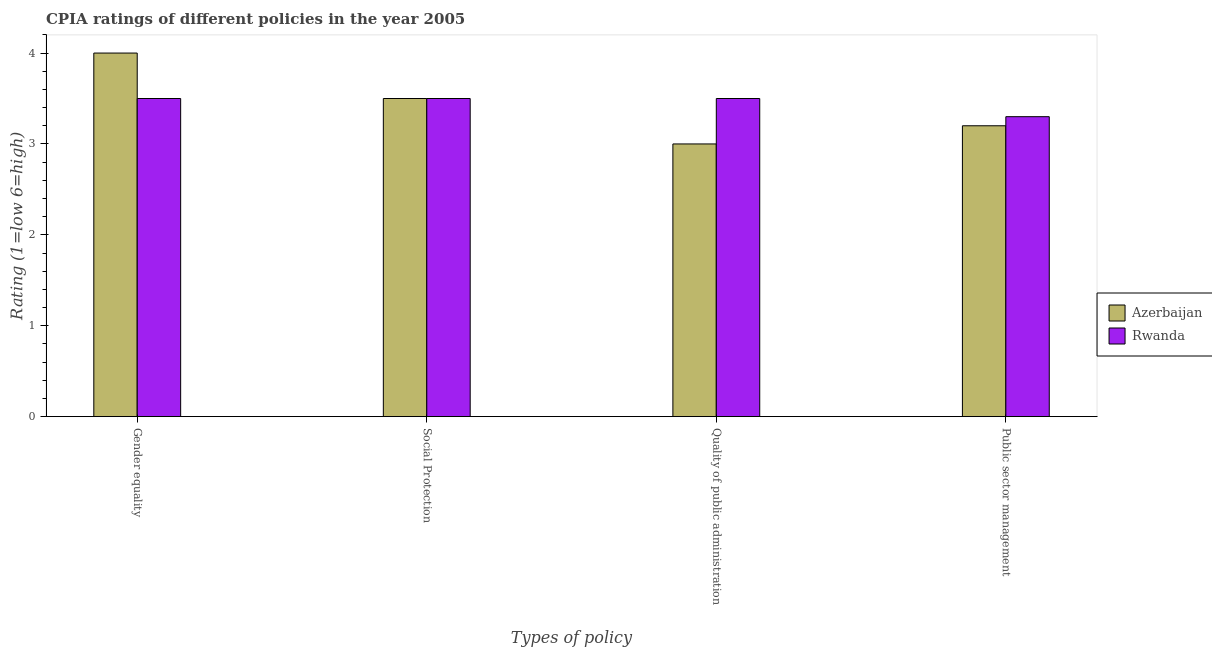How many different coloured bars are there?
Provide a succinct answer. 2. How many groups of bars are there?
Make the answer very short. 4. Are the number of bars on each tick of the X-axis equal?
Keep it short and to the point. Yes. How many bars are there on the 4th tick from the left?
Offer a very short reply. 2. What is the label of the 4th group of bars from the left?
Your answer should be very brief. Public sector management. In which country was the cpia rating of gender equality maximum?
Ensure brevity in your answer.  Azerbaijan. In which country was the cpia rating of social protection minimum?
Offer a very short reply. Azerbaijan. What is the total cpia rating of social protection in the graph?
Make the answer very short. 7. What is the difference between the cpia rating of social protection in Rwanda and that in Azerbaijan?
Keep it short and to the point. 0. What is the average cpia rating of gender equality per country?
Your answer should be very brief. 3.75. What is the difference between the cpia rating of public sector management and cpia rating of social protection in Azerbaijan?
Your answer should be very brief. -0.3. What is the ratio of the cpia rating of quality of public administration in Azerbaijan to that in Rwanda?
Your response must be concise. 0.86. Is the difference between the cpia rating of quality of public administration in Rwanda and Azerbaijan greater than the difference between the cpia rating of social protection in Rwanda and Azerbaijan?
Offer a very short reply. Yes. What is the difference between the highest and the lowest cpia rating of quality of public administration?
Make the answer very short. 0.5. Is the sum of the cpia rating of gender equality in Azerbaijan and Rwanda greater than the maximum cpia rating of public sector management across all countries?
Ensure brevity in your answer.  Yes. What does the 1st bar from the left in Quality of public administration represents?
Provide a succinct answer. Azerbaijan. What does the 1st bar from the right in Quality of public administration represents?
Provide a short and direct response. Rwanda. How many bars are there?
Your answer should be very brief. 8. Are all the bars in the graph horizontal?
Ensure brevity in your answer.  No. What is the difference between two consecutive major ticks on the Y-axis?
Provide a succinct answer. 1. Are the values on the major ticks of Y-axis written in scientific E-notation?
Keep it short and to the point. No. Does the graph contain grids?
Provide a short and direct response. No. How many legend labels are there?
Offer a terse response. 2. How are the legend labels stacked?
Offer a terse response. Vertical. What is the title of the graph?
Provide a succinct answer. CPIA ratings of different policies in the year 2005. What is the label or title of the X-axis?
Provide a short and direct response. Types of policy. What is the Rating (1=low 6=high) in Azerbaijan in Social Protection?
Your answer should be compact. 3.5. What is the Rating (1=low 6=high) in Rwanda in Quality of public administration?
Keep it short and to the point. 3.5. What is the Rating (1=low 6=high) in Azerbaijan in Public sector management?
Provide a short and direct response. 3.2. What is the Rating (1=low 6=high) of Rwanda in Public sector management?
Provide a succinct answer. 3.3. Across all Types of policy, what is the maximum Rating (1=low 6=high) in Azerbaijan?
Your response must be concise. 4. Across all Types of policy, what is the maximum Rating (1=low 6=high) in Rwanda?
Your answer should be very brief. 3.5. Across all Types of policy, what is the minimum Rating (1=low 6=high) of Azerbaijan?
Your answer should be very brief. 3. Across all Types of policy, what is the minimum Rating (1=low 6=high) in Rwanda?
Offer a terse response. 3.3. What is the difference between the Rating (1=low 6=high) of Azerbaijan in Gender equality and that in Social Protection?
Provide a succinct answer. 0.5. What is the difference between the Rating (1=low 6=high) of Rwanda in Gender equality and that in Social Protection?
Ensure brevity in your answer.  0. What is the difference between the Rating (1=low 6=high) of Azerbaijan in Gender equality and that in Public sector management?
Give a very brief answer. 0.8. What is the difference between the Rating (1=low 6=high) of Azerbaijan in Social Protection and that in Quality of public administration?
Make the answer very short. 0.5. What is the difference between the Rating (1=low 6=high) in Azerbaijan in Social Protection and that in Public sector management?
Your answer should be very brief. 0.3. What is the difference between the Rating (1=low 6=high) of Rwanda in Social Protection and that in Public sector management?
Ensure brevity in your answer.  0.2. What is the difference between the Rating (1=low 6=high) of Rwanda in Quality of public administration and that in Public sector management?
Offer a terse response. 0.2. What is the difference between the Rating (1=low 6=high) in Azerbaijan in Gender equality and the Rating (1=low 6=high) in Rwanda in Quality of public administration?
Provide a succinct answer. 0.5. What is the difference between the Rating (1=low 6=high) in Azerbaijan in Gender equality and the Rating (1=low 6=high) in Rwanda in Public sector management?
Make the answer very short. 0.7. What is the difference between the Rating (1=low 6=high) in Azerbaijan in Social Protection and the Rating (1=low 6=high) in Rwanda in Quality of public administration?
Offer a very short reply. 0. What is the difference between the Rating (1=low 6=high) of Azerbaijan in Quality of public administration and the Rating (1=low 6=high) of Rwanda in Public sector management?
Your answer should be compact. -0.3. What is the average Rating (1=low 6=high) in Azerbaijan per Types of policy?
Offer a terse response. 3.42. What is the average Rating (1=low 6=high) in Rwanda per Types of policy?
Provide a succinct answer. 3.45. What is the difference between the Rating (1=low 6=high) of Azerbaijan and Rating (1=low 6=high) of Rwanda in Quality of public administration?
Your answer should be very brief. -0.5. What is the difference between the Rating (1=low 6=high) in Azerbaijan and Rating (1=low 6=high) in Rwanda in Public sector management?
Make the answer very short. -0.1. What is the ratio of the Rating (1=low 6=high) of Azerbaijan in Gender equality to that in Social Protection?
Offer a terse response. 1.14. What is the ratio of the Rating (1=low 6=high) in Rwanda in Gender equality to that in Public sector management?
Your response must be concise. 1.06. What is the ratio of the Rating (1=low 6=high) of Azerbaijan in Social Protection to that in Public sector management?
Offer a terse response. 1.09. What is the ratio of the Rating (1=low 6=high) of Rwanda in Social Protection to that in Public sector management?
Offer a terse response. 1.06. What is the ratio of the Rating (1=low 6=high) in Azerbaijan in Quality of public administration to that in Public sector management?
Make the answer very short. 0.94. What is the ratio of the Rating (1=low 6=high) in Rwanda in Quality of public administration to that in Public sector management?
Give a very brief answer. 1.06. What is the difference between the highest and the second highest Rating (1=low 6=high) of Rwanda?
Provide a succinct answer. 0. What is the difference between the highest and the lowest Rating (1=low 6=high) of Rwanda?
Your answer should be very brief. 0.2. 